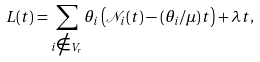Convert formula to latex. <formula><loc_0><loc_0><loc_500><loc_500>L ( t ) = \sum _ { i \notin V _ { r } } \theta _ { i } \left ( \mathcal { N } _ { i } ( t ) - ( \theta _ { i } / \mu ) t \right ) + \lambda t ,</formula> 